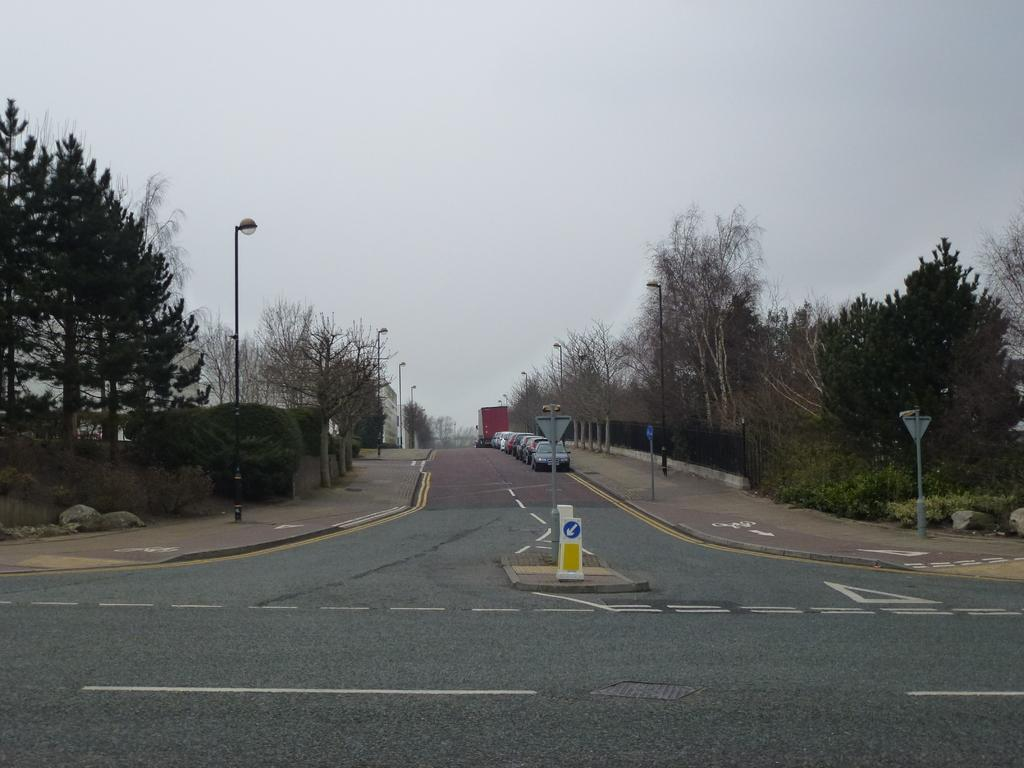What type of vegetation can be seen in the image? There are trees in the image. What type of transportation is visible on the road in the image? Cars are visible on the road in the image. What structure can be seen in the image? There is a pole in the image. What is attached to the pole in the image? There is a light attached to the pole in the image. What is visible in the background of the image? The sky is visible in the image. Can you see a rabbit regretting a bite it took from a carrot in the image? There is no rabbit or carrot present in the image, and therefore no such activity can be observed. 